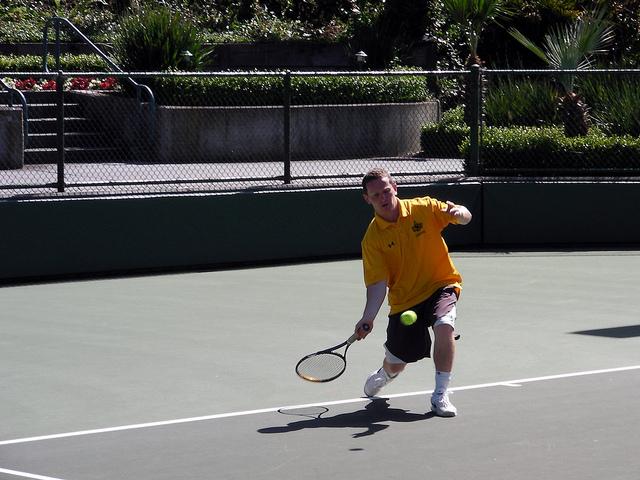What is the man playing?
Be succinct. Tennis. What color is the ball?
Give a very brief answer. Yellow. How many steps are on the staircase?
Quick response, please. 5. 